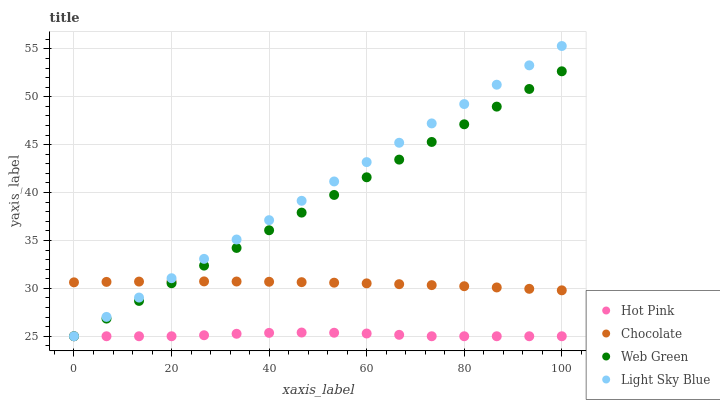Does Hot Pink have the minimum area under the curve?
Answer yes or no. Yes. Does Light Sky Blue have the maximum area under the curve?
Answer yes or no. Yes. Does Web Green have the minimum area under the curve?
Answer yes or no. No. Does Web Green have the maximum area under the curve?
Answer yes or no. No. Is Light Sky Blue the smoothest?
Answer yes or no. Yes. Is Hot Pink the roughest?
Answer yes or no. Yes. Is Web Green the smoothest?
Answer yes or no. No. Is Web Green the roughest?
Answer yes or no. No. Does Light Sky Blue have the lowest value?
Answer yes or no. Yes. Does Chocolate have the lowest value?
Answer yes or no. No. Does Light Sky Blue have the highest value?
Answer yes or no. Yes. Does Web Green have the highest value?
Answer yes or no. No. Is Hot Pink less than Chocolate?
Answer yes or no. Yes. Is Chocolate greater than Hot Pink?
Answer yes or no. Yes. Does Chocolate intersect Web Green?
Answer yes or no. Yes. Is Chocolate less than Web Green?
Answer yes or no. No. Is Chocolate greater than Web Green?
Answer yes or no. No. Does Hot Pink intersect Chocolate?
Answer yes or no. No. 